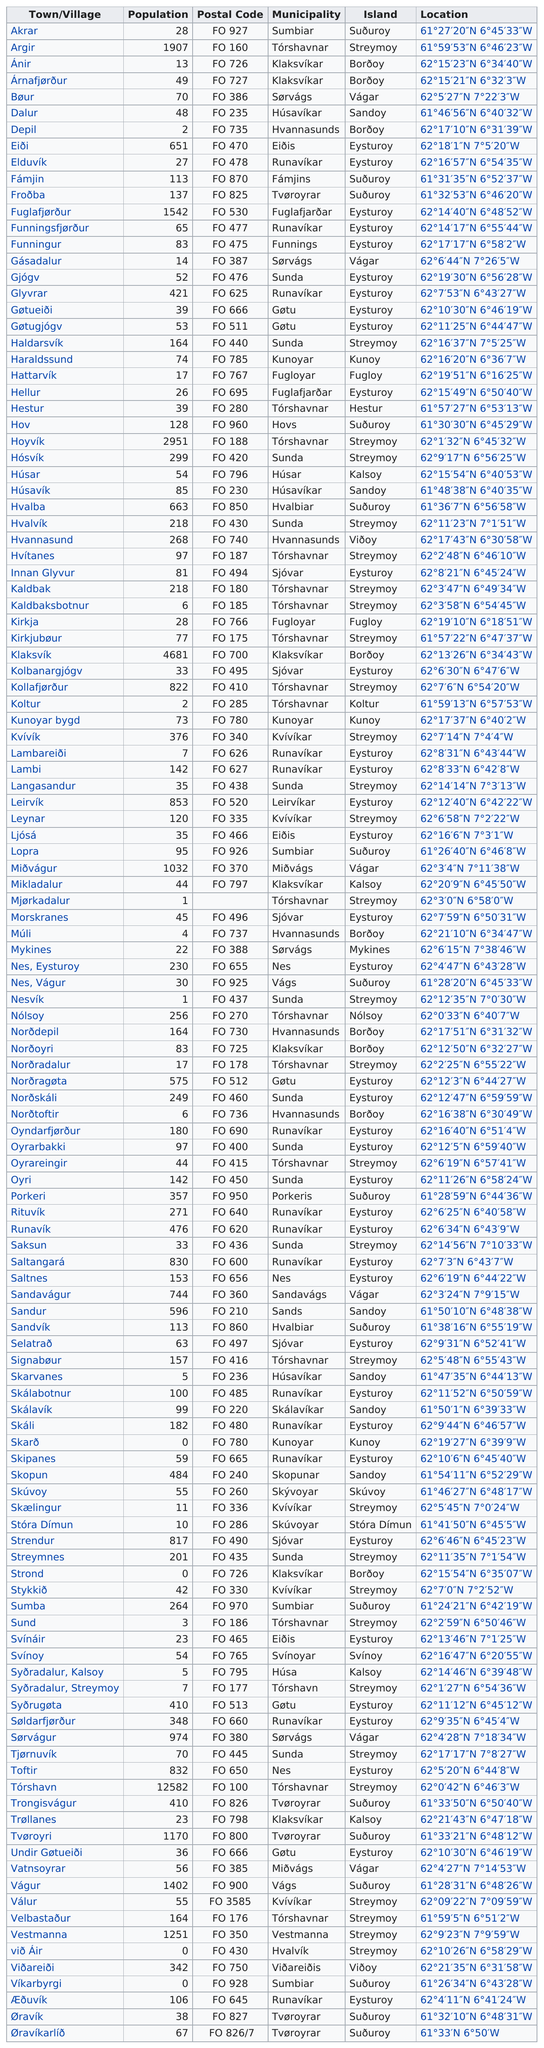Point out several critical features in this image. Tórshavn has the highest number of people among all towns and villages. Akrar would come first in alphabetical order among all the towns in the Faroe Islands. Argir has a population of 1907 people. The island of Akrar is listed before the town/village of Argir in a list. Fámjin and froðba are located on the island of Suðuroy. 